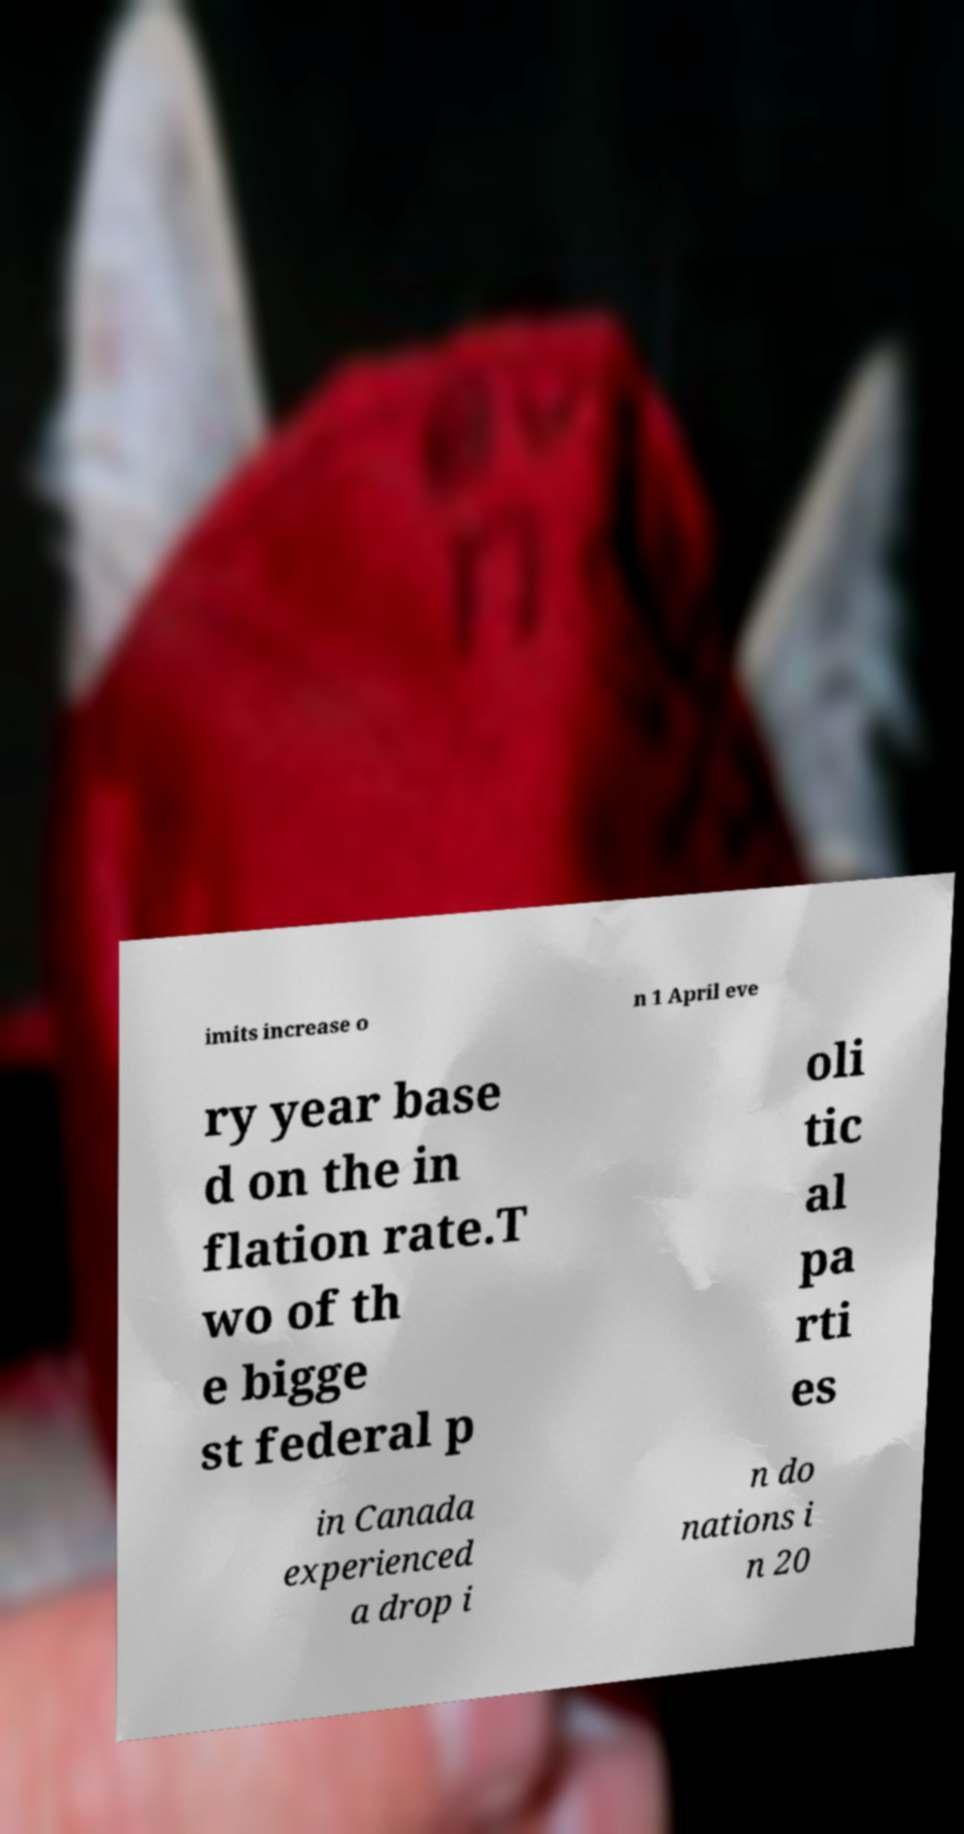There's text embedded in this image that I need extracted. Can you transcribe it verbatim? imits increase o n 1 April eve ry year base d on the in flation rate.T wo of th e bigge st federal p oli tic al pa rti es in Canada experienced a drop i n do nations i n 20 